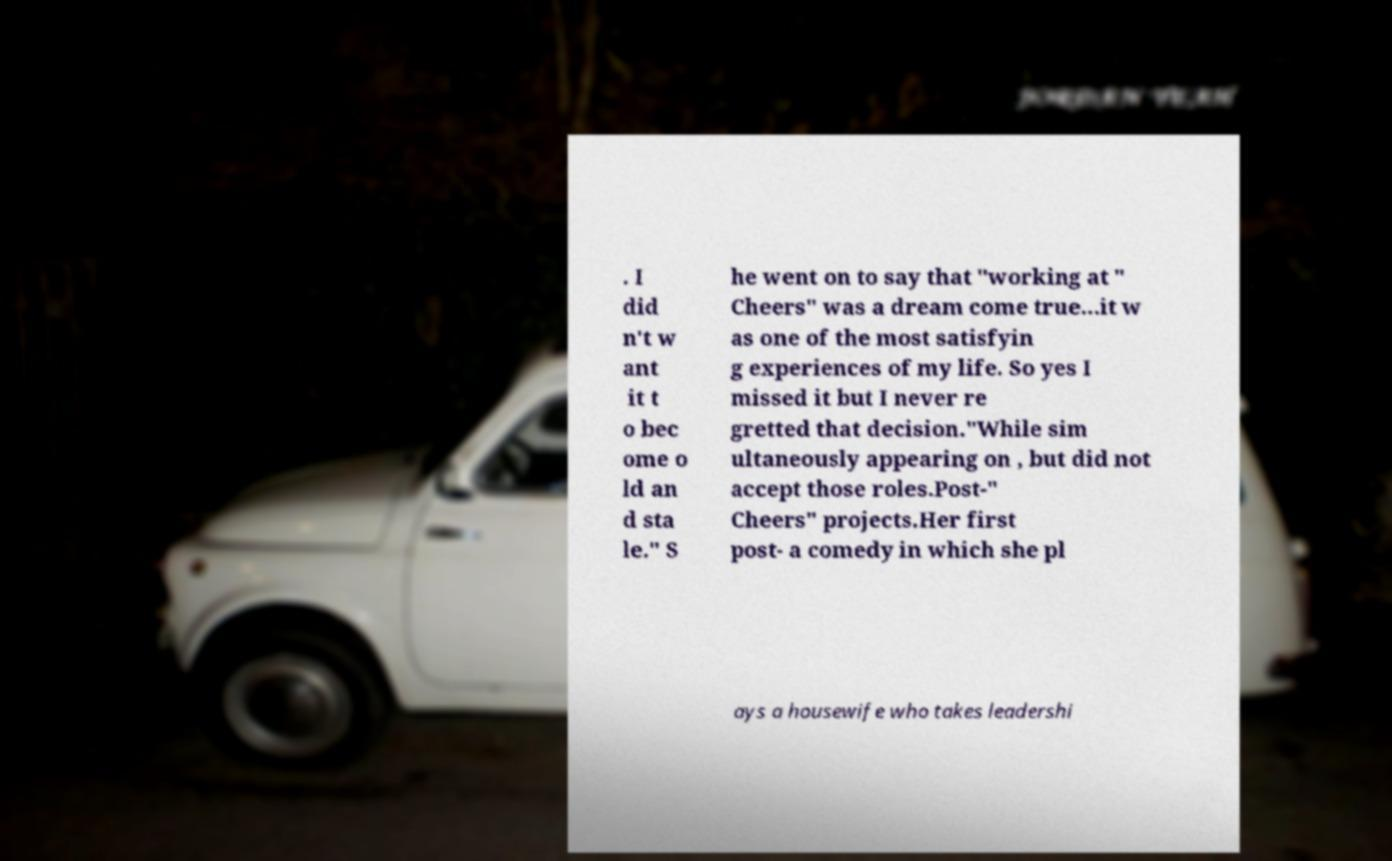Please read and relay the text visible in this image. What does it say? . I did n't w ant it t o bec ome o ld an d sta le." S he went on to say that "working at " Cheers" was a dream come true...it w as one of the most satisfyin g experiences of my life. So yes I missed it but I never re gretted that decision."While sim ultaneously appearing on , but did not accept those roles.Post-" Cheers" projects.Her first post- a comedy in which she pl ays a housewife who takes leadershi 